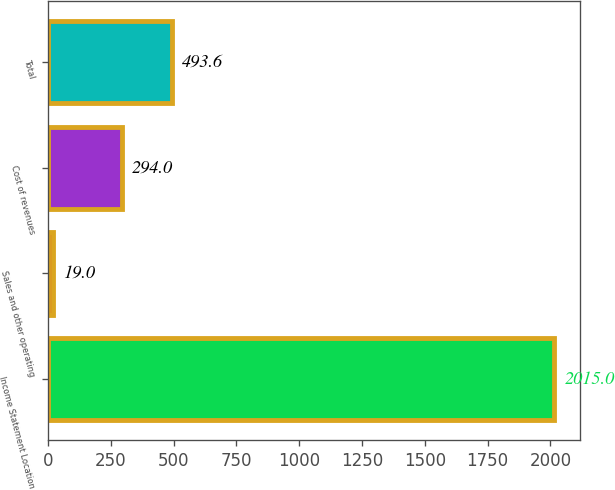Convert chart to OTSL. <chart><loc_0><loc_0><loc_500><loc_500><bar_chart><fcel>Income Statement Location<fcel>Sales and other operating<fcel>Cost of revenues<fcel>Total<nl><fcel>2015<fcel>19<fcel>294<fcel>493.6<nl></chart> 